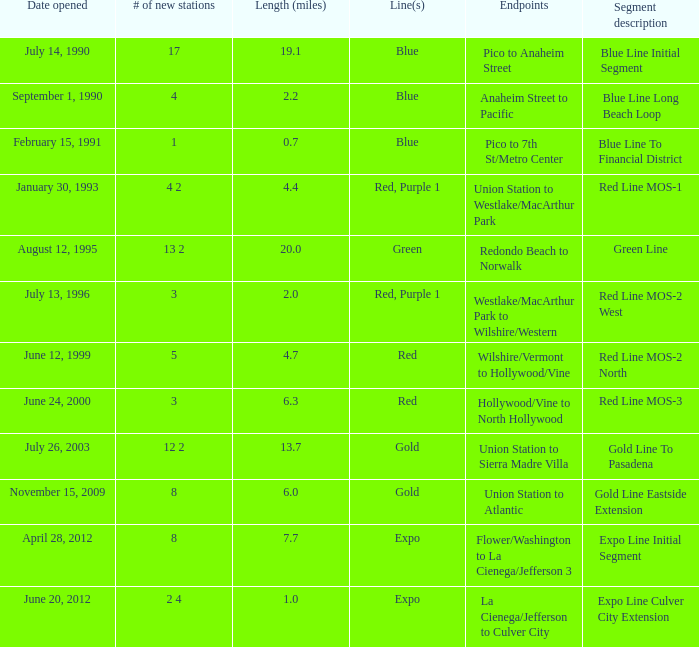How many new stations have a lenght (miles) of 6.0? 1.0. 